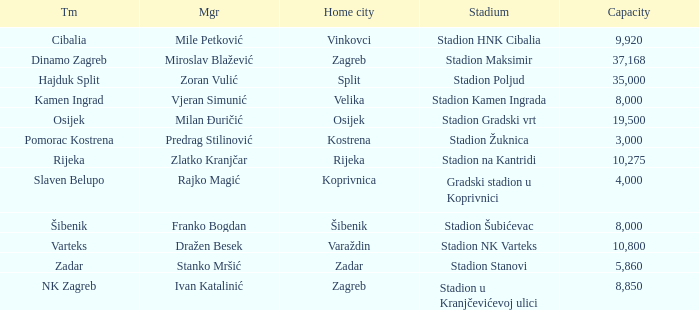Would you mind parsing the complete table? {'header': ['Tm', 'Mgr', 'Home city', 'Stadium', 'Capacity'], 'rows': [['Cibalia', 'Mile Petković', 'Vinkovci', 'Stadion HNK Cibalia', '9,920'], ['Dinamo Zagreb', 'Miroslav Blažević', 'Zagreb', 'Stadion Maksimir', '37,168'], ['Hajduk Split', 'Zoran Vulić', 'Split', 'Stadion Poljud', '35,000'], ['Kamen Ingrad', 'Vjeran Simunić', 'Velika', 'Stadion Kamen Ingrada', '8,000'], ['Osijek', 'Milan Đuričić', 'Osijek', 'Stadion Gradski vrt', '19,500'], ['Pomorac Kostrena', 'Predrag Stilinović', 'Kostrena', 'Stadion Žuknica', '3,000'], ['Rijeka', 'Zlatko Kranjčar', 'Rijeka', 'Stadion na Kantridi', '10,275'], ['Slaven Belupo', 'Rajko Magić', 'Koprivnica', 'Gradski stadion u Koprivnici', '4,000'], ['Šibenik', 'Franko Bogdan', 'Šibenik', 'Stadion Šubićevac', '8,000'], ['Varteks', 'Dražen Besek', 'Varaždin', 'Stadion NK Varteks', '10,800'], ['Zadar', 'Stanko Mršić', 'Zadar', 'Stadion Stanovi', '5,860'], ['NK Zagreb', 'Ivan Katalinić', 'Zagreb', 'Stadion u Kranjčevićevoj ulici', '8,850']]} What is the stadium of the NK Zagreb? Stadion u Kranjčevićevoj ulici. 